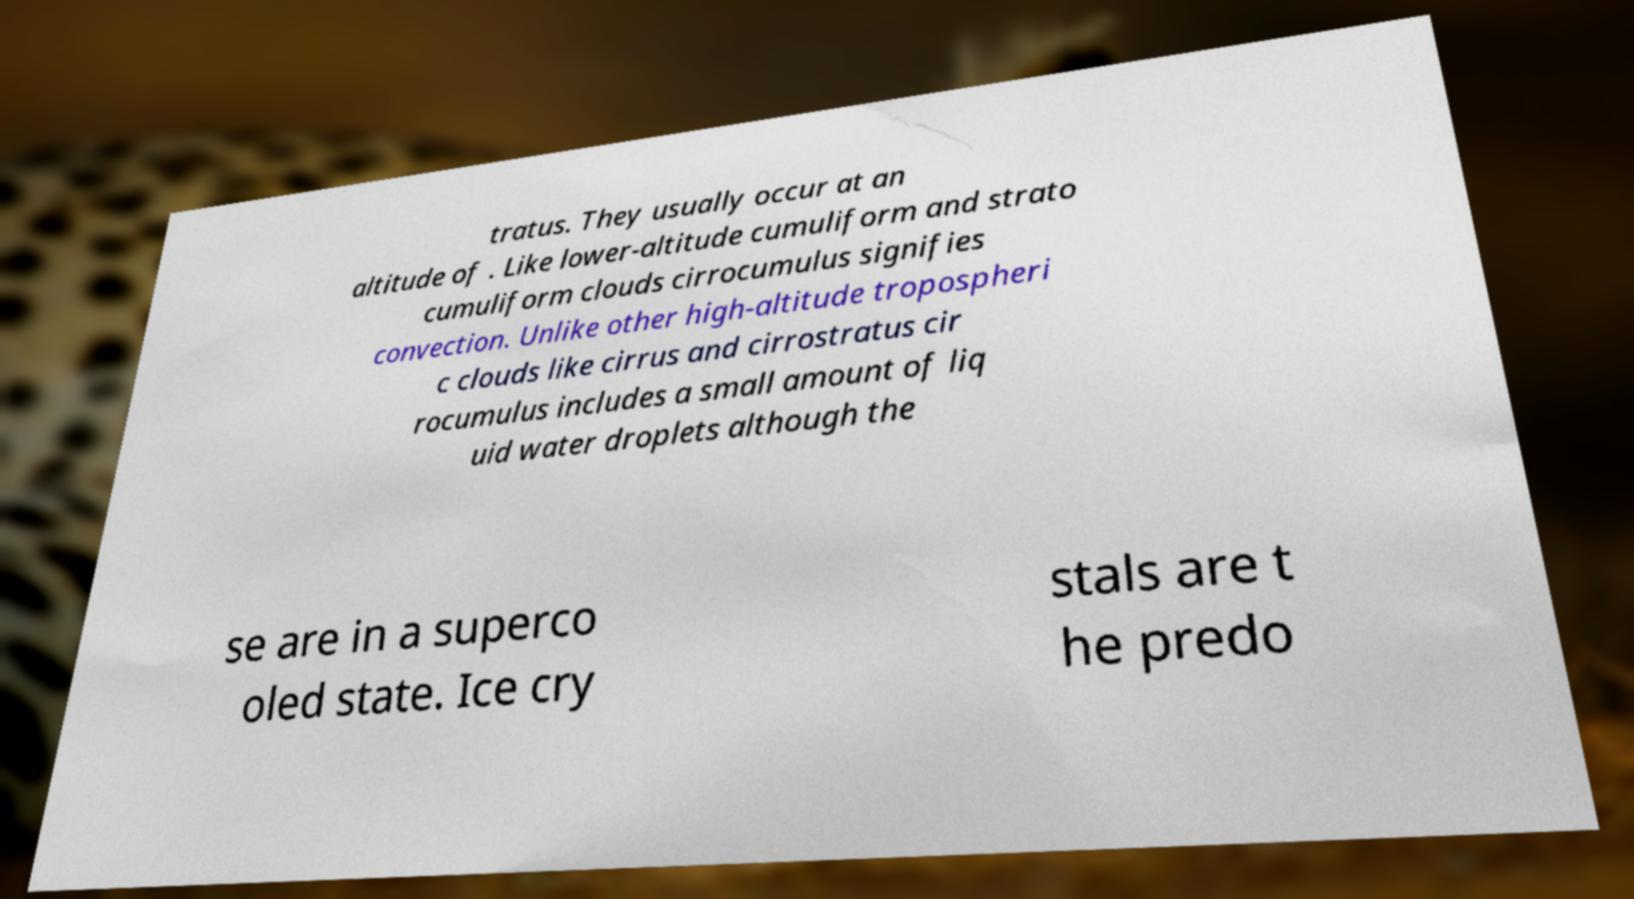There's text embedded in this image that I need extracted. Can you transcribe it verbatim? tratus. They usually occur at an altitude of . Like lower-altitude cumuliform and strato cumuliform clouds cirrocumulus signifies convection. Unlike other high-altitude tropospheri c clouds like cirrus and cirrostratus cir rocumulus includes a small amount of liq uid water droplets although the se are in a superco oled state. Ice cry stals are t he predo 